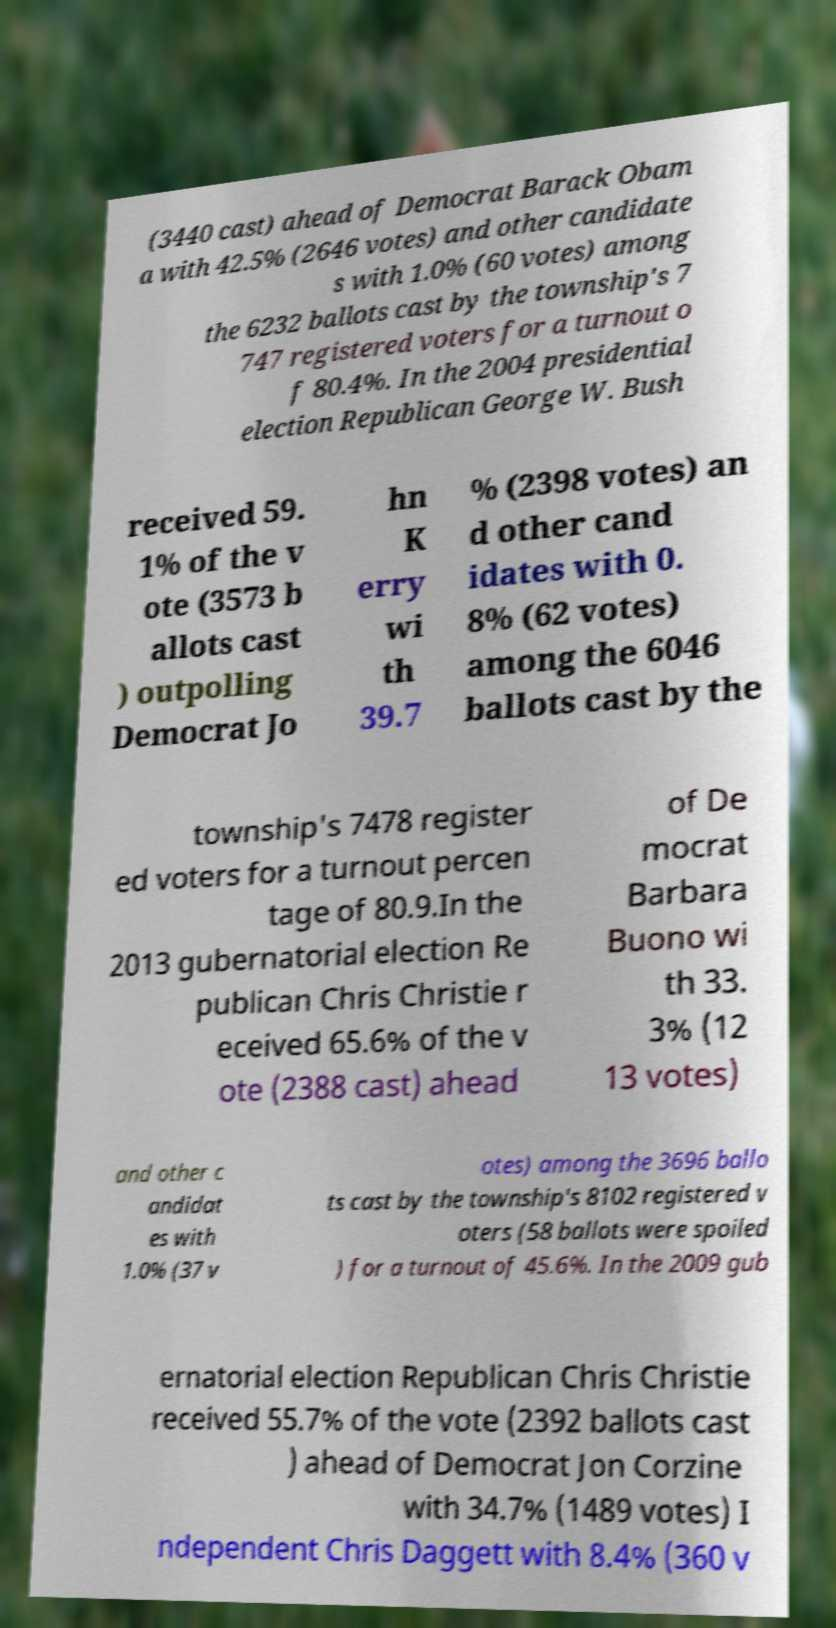Please identify and transcribe the text found in this image. (3440 cast) ahead of Democrat Barack Obam a with 42.5% (2646 votes) and other candidate s with 1.0% (60 votes) among the 6232 ballots cast by the township's 7 747 registered voters for a turnout o f 80.4%. In the 2004 presidential election Republican George W. Bush received 59. 1% of the v ote (3573 b allots cast ) outpolling Democrat Jo hn K erry wi th 39.7 % (2398 votes) an d other cand idates with 0. 8% (62 votes) among the 6046 ballots cast by the township's 7478 register ed voters for a turnout percen tage of 80.9.In the 2013 gubernatorial election Re publican Chris Christie r eceived 65.6% of the v ote (2388 cast) ahead of De mocrat Barbara Buono wi th 33. 3% (12 13 votes) and other c andidat es with 1.0% (37 v otes) among the 3696 ballo ts cast by the township's 8102 registered v oters (58 ballots were spoiled ) for a turnout of 45.6%. In the 2009 gub ernatorial election Republican Chris Christie received 55.7% of the vote (2392 ballots cast ) ahead of Democrat Jon Corzine with 34.7% (1489 votes) I ndependent Chris Daggett with 8.4% (360 v 